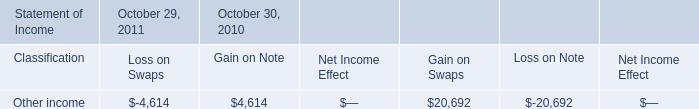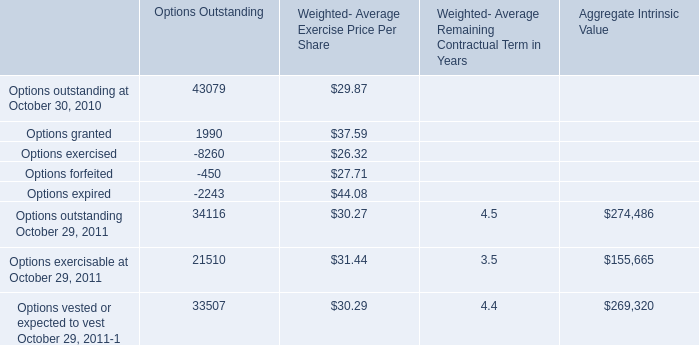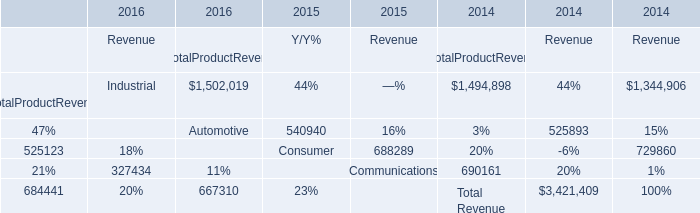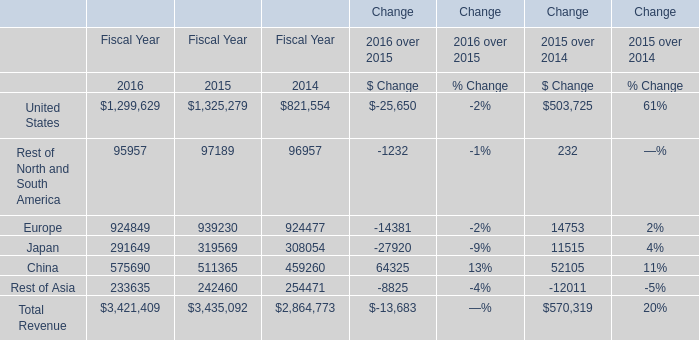What's the sum of China of Change Fiscal Year 2015, Options expired of Options Outstanding, and Other income of October 30, 2010 Gain on Swaps ? 
Computations: ((511365.0 + 2243.0) + 20692.0)
Answer: 534300.0. 